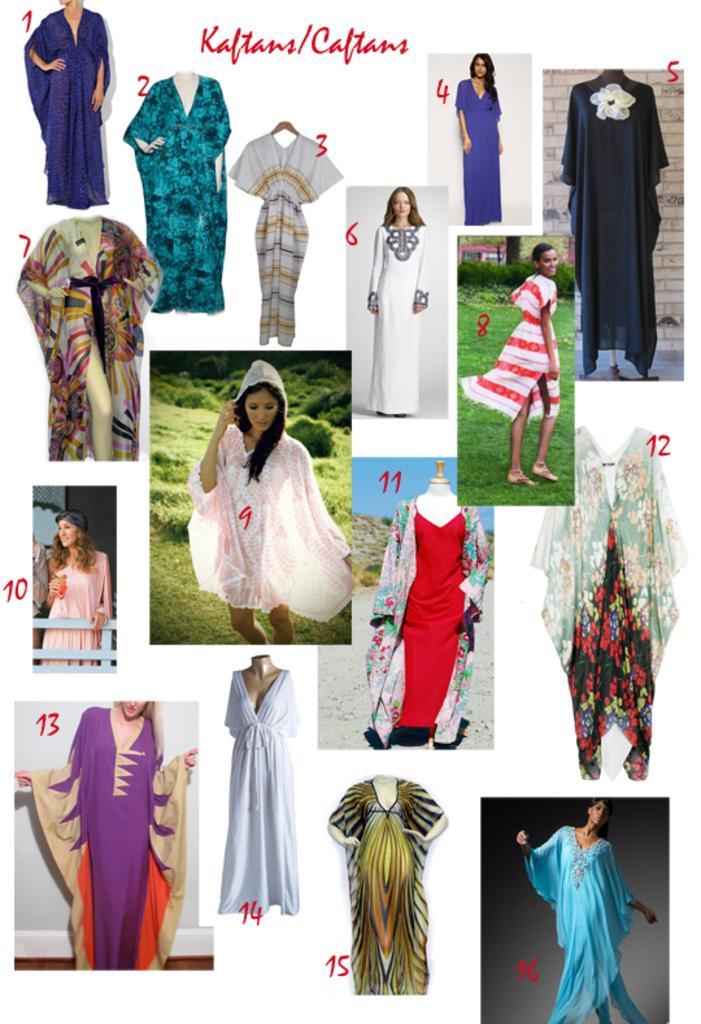Please provide a concise description of this image. In this image we can see different types of costumes for a woman, which are labelled with numbers. Here we can see some text. 